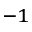<formula> <loc_0><loc_0><loc_500><loc_500>^ { - 1 }</formula> 